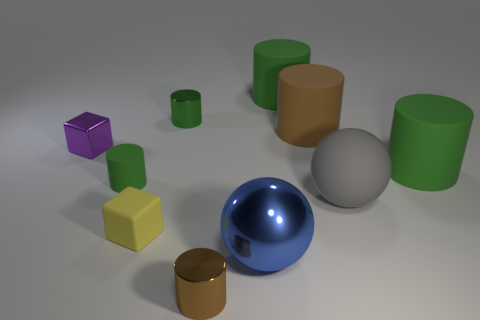There is a matte thing on the right side of the gray ball; is it the same shape as the brown rubber object?
Give a very brief answer. Yes. What color is the large metallic object?
Give a very brief answer. Blue. There is a small rubber object that is the same shape as the green metal object; what color is it?
Ensure brevity in your answer.  Green. What number of other objects are the same shape as the tiny purple thing?
Your answer should be compact. 1. How many objects are metal cubes or cylinders behind the purple block?
Your answer should be very brief. 4. Do the metal ball and the tiny metal cylinder in front of the small matte block have the same color?
Your answer should be very brief. No. What size is the thing that is to the left of the brown metal thing and in front of the tiny rubber cylinder?
Make the answer very short. Small. There is a big gray thing; are there any small yellow cubes behind it?
Keep it short and to the point. No. There is a rubber cylinder right of the rubber ball; are there any green cylinders that are to the right of it?
Provide a short and direct response. No. Are there the same number of blue shiny things that are behind the small purple object and large shiny things to the left of the green shiny thing?
Make the answer very short. Yes. 